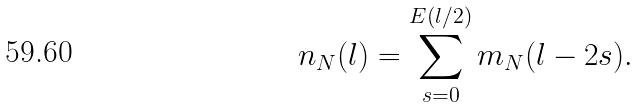Convert formula to latex. <formula><loc_0><loc_0><loc_500><loc_500>n _ { N } ( l ) = \sum _ { s = 0 } ^ { E ( l / 2 ) } m _ { N } ( l - 2 s ) .</formula> 